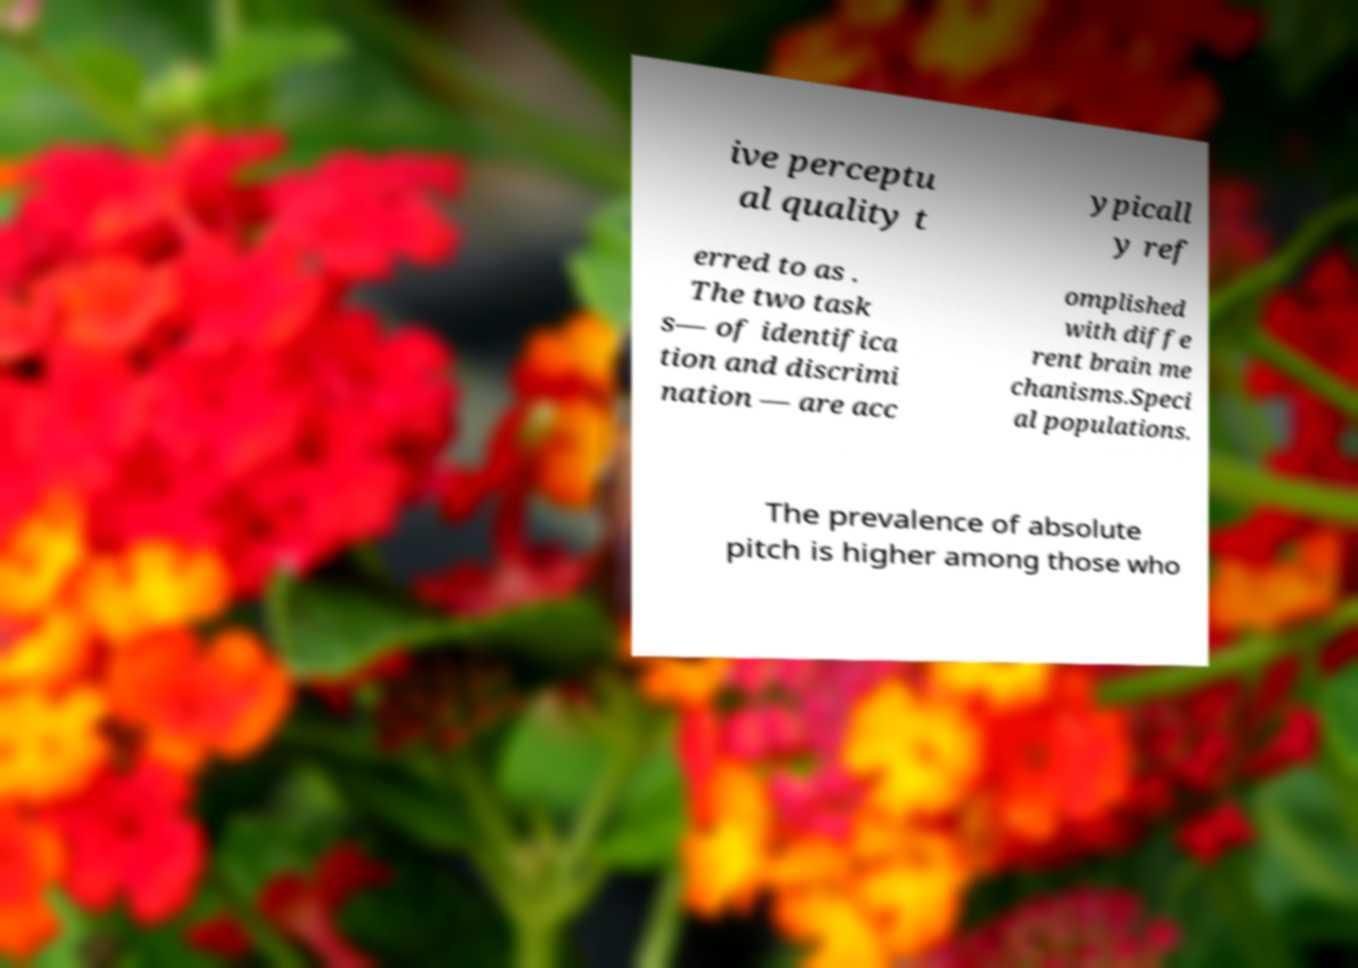What messages or text are displayed in this image? I need them in a readable, typed format. ive perceptu al quality t ypicall y ref erred to as . The two task s— of identifica tion and discrimi nation — are acc omplished with diffe rent brain me chanisms.Speci al populations. The prevalence of absolute pitch is higher among those who 